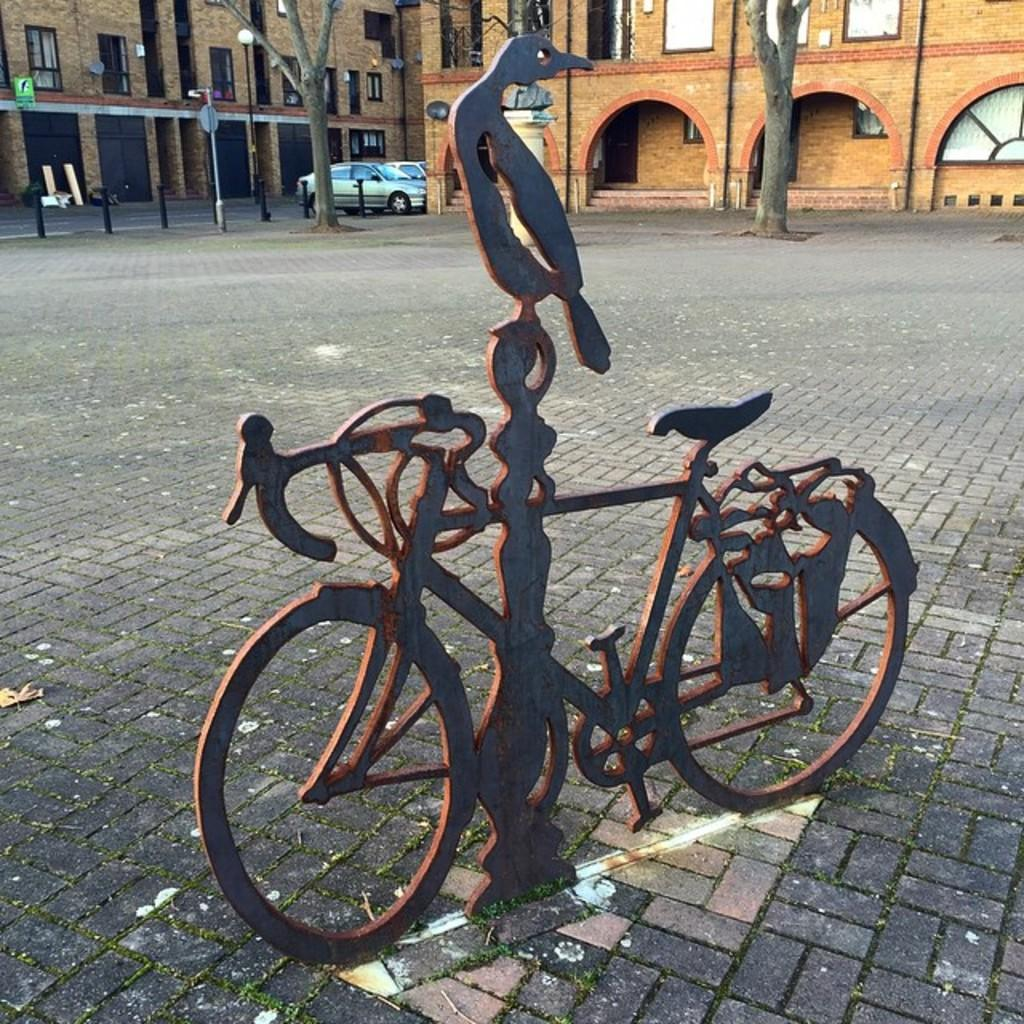What is the main subject of the statue in the image? The statue in the image is of a bicycle. What type of structures can be seen in the image? There are buildings in the image. What natural elements are visible in the image? Tree trunks are visible in the image. What are the poles used for in the image? The purpose of the poles in the image is not specified, but they could be used for various purposes such as signage or lighting. What is the board used for in the image? The purpose of the board in the image is not specified, but it could be used for displaying information or advertisements. What type of vehicles can be seen on the ground in the image? Vehicles are on the ground in the image, but their specific types are not mentioned. How many cherries are hanging from the bicycle statue in the image? There are no cherries present in the image, as the statue is of a bicycle. What type of shoe is the daughter wearing in the image? There is no daughter or shoe present in the image. 